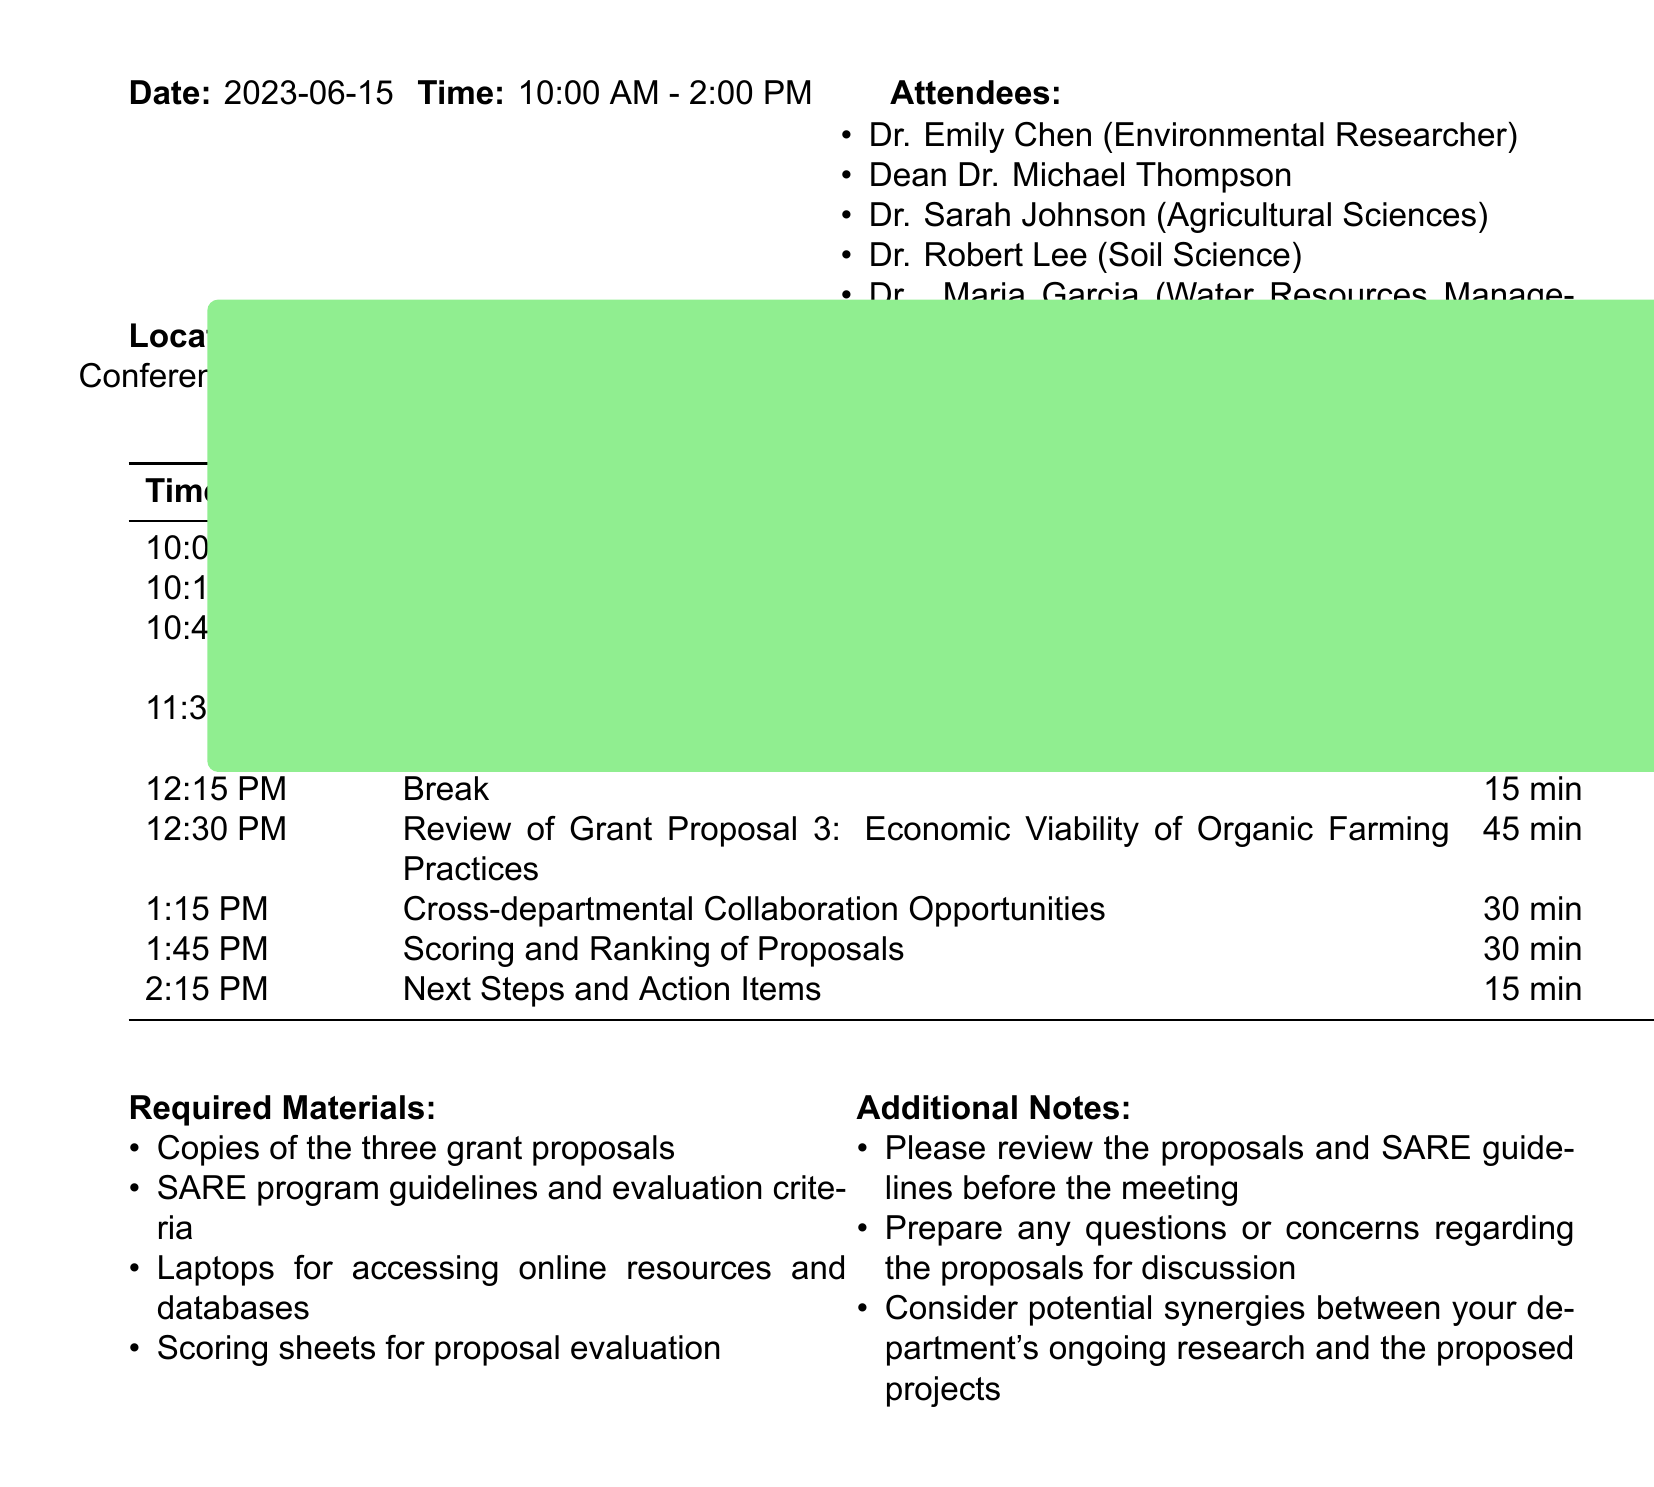What is the date of the meeting? The date of the meeting is stated at the beginning of the document.
Answer: 2023-06-15 Who is reviewing the first grant proposal? The first grant proposal is reviewed by the attendees listed in the meeting agenda.
Answer: Dr. Sarah Johnson What is the duration of the break? The break duration is indicated within the agenda items section.
Answer: 15 minutes What type of proposals are being reviewed? The document mentions various types of grant proposals focused on sustainable agriculture.
Answer: Sustainable agriculture What is the title of the second grant proposal? The title is explicitly stated in the agenda items of the document.
Answer: Soil Microbiome Enhancement for Crop Resilience How long is allocated for scoring and ranking of proposals? The duration for this agenda item is provided in the table summarizing the meeting schedule.
Answer: 30 minutes What materials are required for the meeting? The required materials are listed at the end of the document.
Answer: Copies of the three grant proposals Who are the attendees from Agricultural Sciences? The attendees' names and their departments are provided in the attendee list of the document.
Answer: Dr. Sarah Johnson What is the purpose of the meeting? The purpose is derived from the meeting title and agenda items described in the document.
Answer: Review of grant proposals 